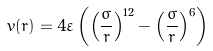<formula> <loc_0><loc_0><loc_500><loc_500>v ( r ) = 4 \varepsilon \left ( \left ( \frac { \sigma } { r } \right ) ^ { 1 2 } - \left ( \frac { \sigma } { r } \right ) ^ { 6 } \right )</formula> 